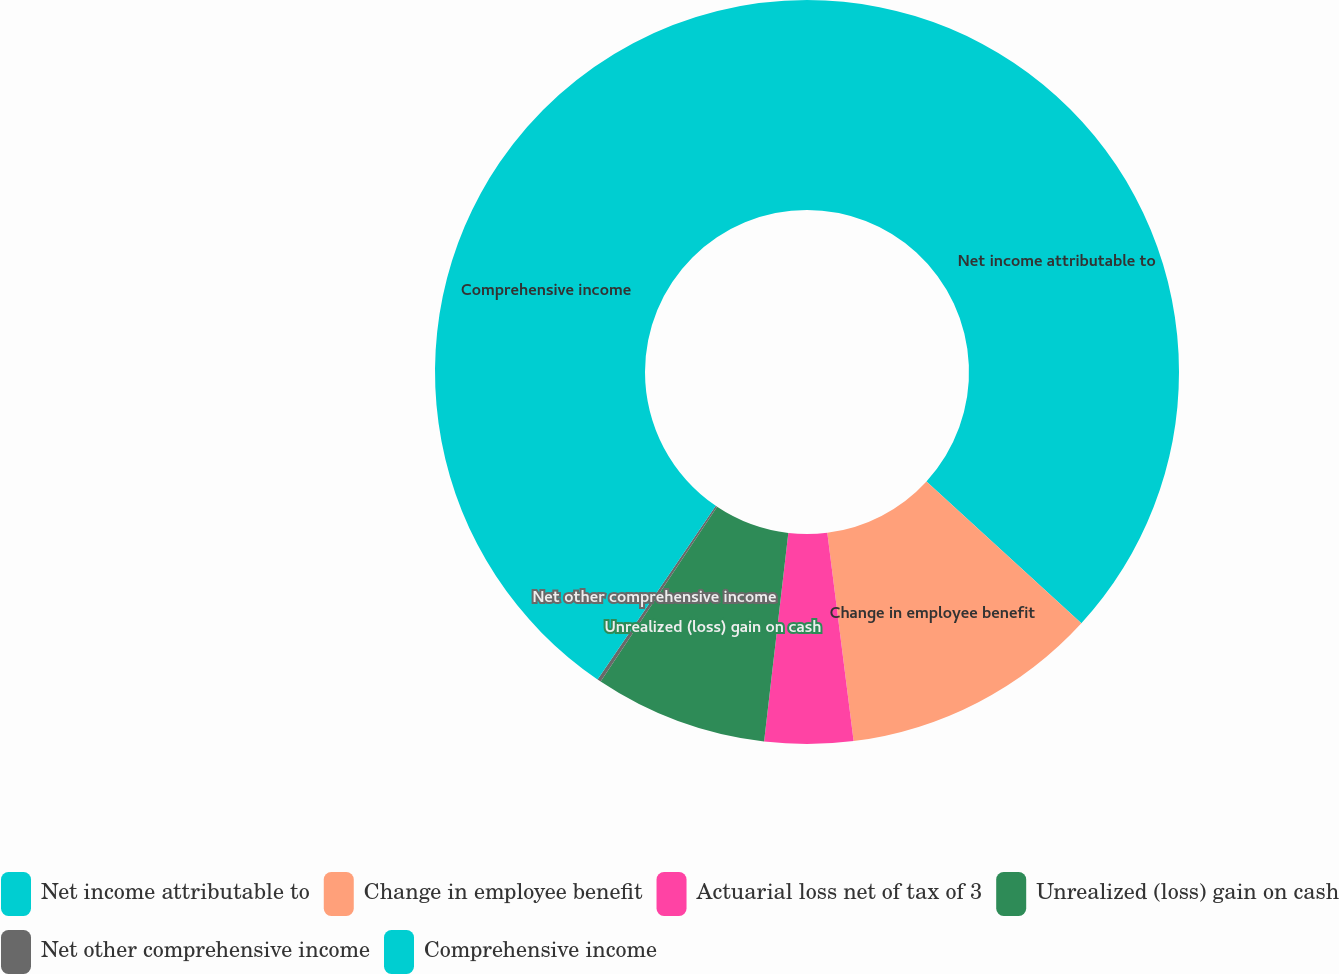Convert chart. <chart><loc_0><loc_0><loc_500><loc_500><pie_chart><fcel>Net income attributable to<fcel>Change in employee benefit<fcel>Actuarial loss net of tax of 3<fcel>Unrealized (loss) gain on cash<fcel>Net other comprehensive income<fcel>Comprehensive income<nl><fcel>36.8%<fcel>11.2%<fcel>3.84%<fcel>7.52%<fcel>0.16%<fcel>40.48%<nl></chart> 